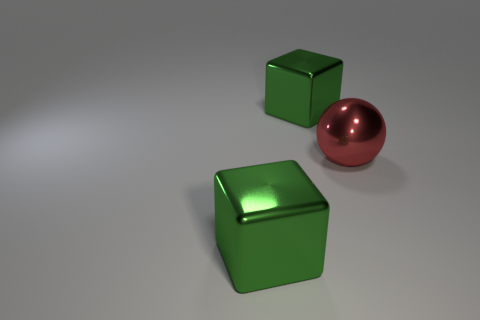How many objects are either shiny blocks or big red objects?
Your answer should be compact. 3. There is a green shiny thing that is behind the red shiny thing; are there any metal cubes right of it?
Keep it short and to the point. No. What number of other large balls have the same color as the big sphere?
Your response must be concise. 0. There is a metal block in front of the large metallic ball; is it the same color as the large block that is behind the big red shiny object?
Offer a terse response. Yes. There is a big sphere; are there any metallic balls in front of it?
Offer a terse response. No. What material is the red ball?
Your answer should be very brief. Metal. Is there a brown shiny sphere that has the same size as the red shiny thing?
Keep it short and to the point. No. How many large balls are right of the big red shiny sphere?
Ensure brevity in your answer.  0. How many other objects are there of the same shape as the big red thing?
Provide a short and direct response. 0. Is the number of large yellow things less than the number of big green metallic objects?
Your answer should be very brief. Yes. 